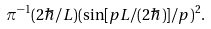Convert formula to latex. <formula><loc_0><loc_0><loc_500><loc_500>\pi ^ { - 1 } ( 2 \hbar { / } L ) ( \sin [ p L / ( 2 \hbar { ) } ] / p ) ^ { 2 } .</formula> 